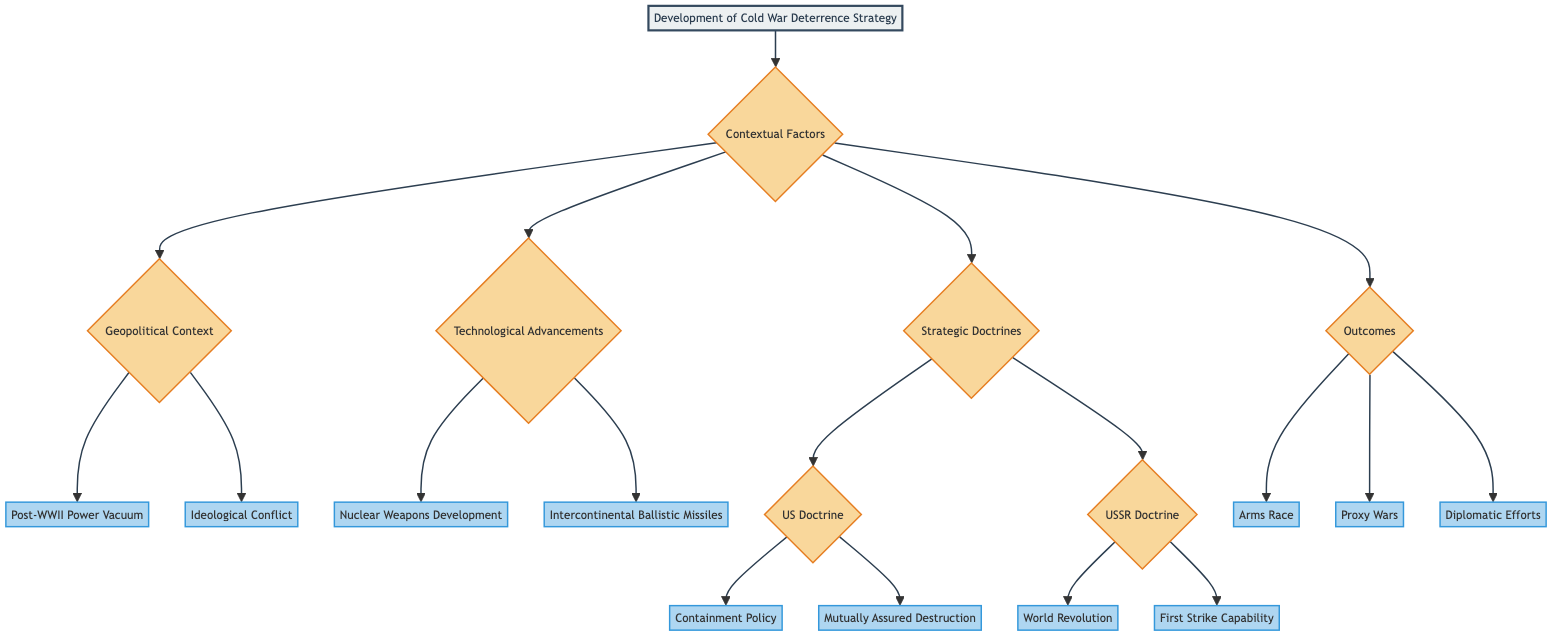What are the two main contextual factors in the diagram? The diagram highlights two main contextual factors: **Geopolitical Context** and **Technological Advancements** as branches stemming from Contextual Factors.
Answer: Geopolitical Context, Technological Advancements What is the US Doctrine mentioned in the diagram? Based on the diagram, the two US doctrines are **Containment Policy** and **Mutually Assured Destruction (MAD)**.
Answer: Containment Policy, Mutually Assured Destruction How many endpoint nodes are there in total? The diagram includes 8 endpoint nodes (two from each of the four main categories: Geopolitical Context, Technological Advancements, US Doctrine, and USSR Doctrine).
Answer: 8 What does the USSR doctrine of "World Revolution" aim for? According to the diagram, the "World Revolution" doctrine aims to promote communism globally through support of allies.
Answer: Promote communism globally Which outcome is primarily associated with the arms race in the diagram? The diagram indicates that the arms race resulted in the **massive accumulation of nuclear arsenal by both superpowers** as a key endpoint outcome.
Answer: Massive accumulation of nuclear arsenal What is the relationship between "Post-WWII Power Vacuum" and "Proxy Wars"? The "Post-WWII Power Vacuum" leads to increased competition for influence, which in turn is related to indirect superpower confrontations symbolized by **Proxy Wars** as one of the outcomes in the diagram.
Answer: Leads to indirect confrontations What does MAD ensure as a strategic doctrine? The diagram states that "Mutually Assured Destruction (MAD)" ensures deterrence through a **guaranteed retaliatory strike**, indicating a key aspect of U.S. deterrence strategy.
Answer: Guaranteed retaliatory strike Which two technological advancements are listed in the diagram? The diagram presents two technological advancements that influenced deterrence strategies: **Nuclear Weapons Development** and **Intercontinental Ballistic Missiles (ICBMs)**.
Answer: Nuclear Weapons Development, Intercontinental Ballistic Missiles What is the primary goal of the strategic doctrine termed "First Strike Capability"? According to the diagram, the goal of the "First Strike Capability" is to gain a **strategic advantage by threatening preemptive strikes**.
Answer: Gain strategic advantage 